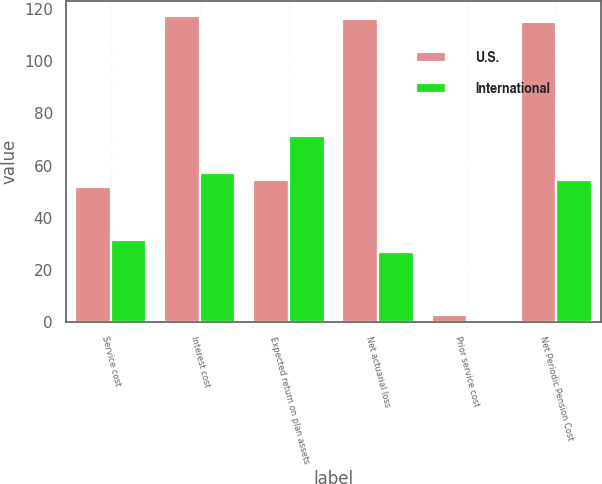Convert chart to OTSL. <chart><loc_0><loc_0><loc_500><loc_500><stacked_bar_chart><ecel><fcel>Service cost<fcel>Interest cost<fcel>Expected return on plan assets<fcel>Net actuarial loss<fcel>Prior service cost<fcel>Net Periodic Pension Cost<nl><fcel>U.S.<fcel>51.8<fcel>117.1<fcel>54.6<fcel>116<fcel>2.9<fcel>115.1<nl><fcel>International<fcel>31.5<fcel>57.3<fcel>71.2<fcel>27<fcel>0.2<fcel>54.6<nl></chart> 